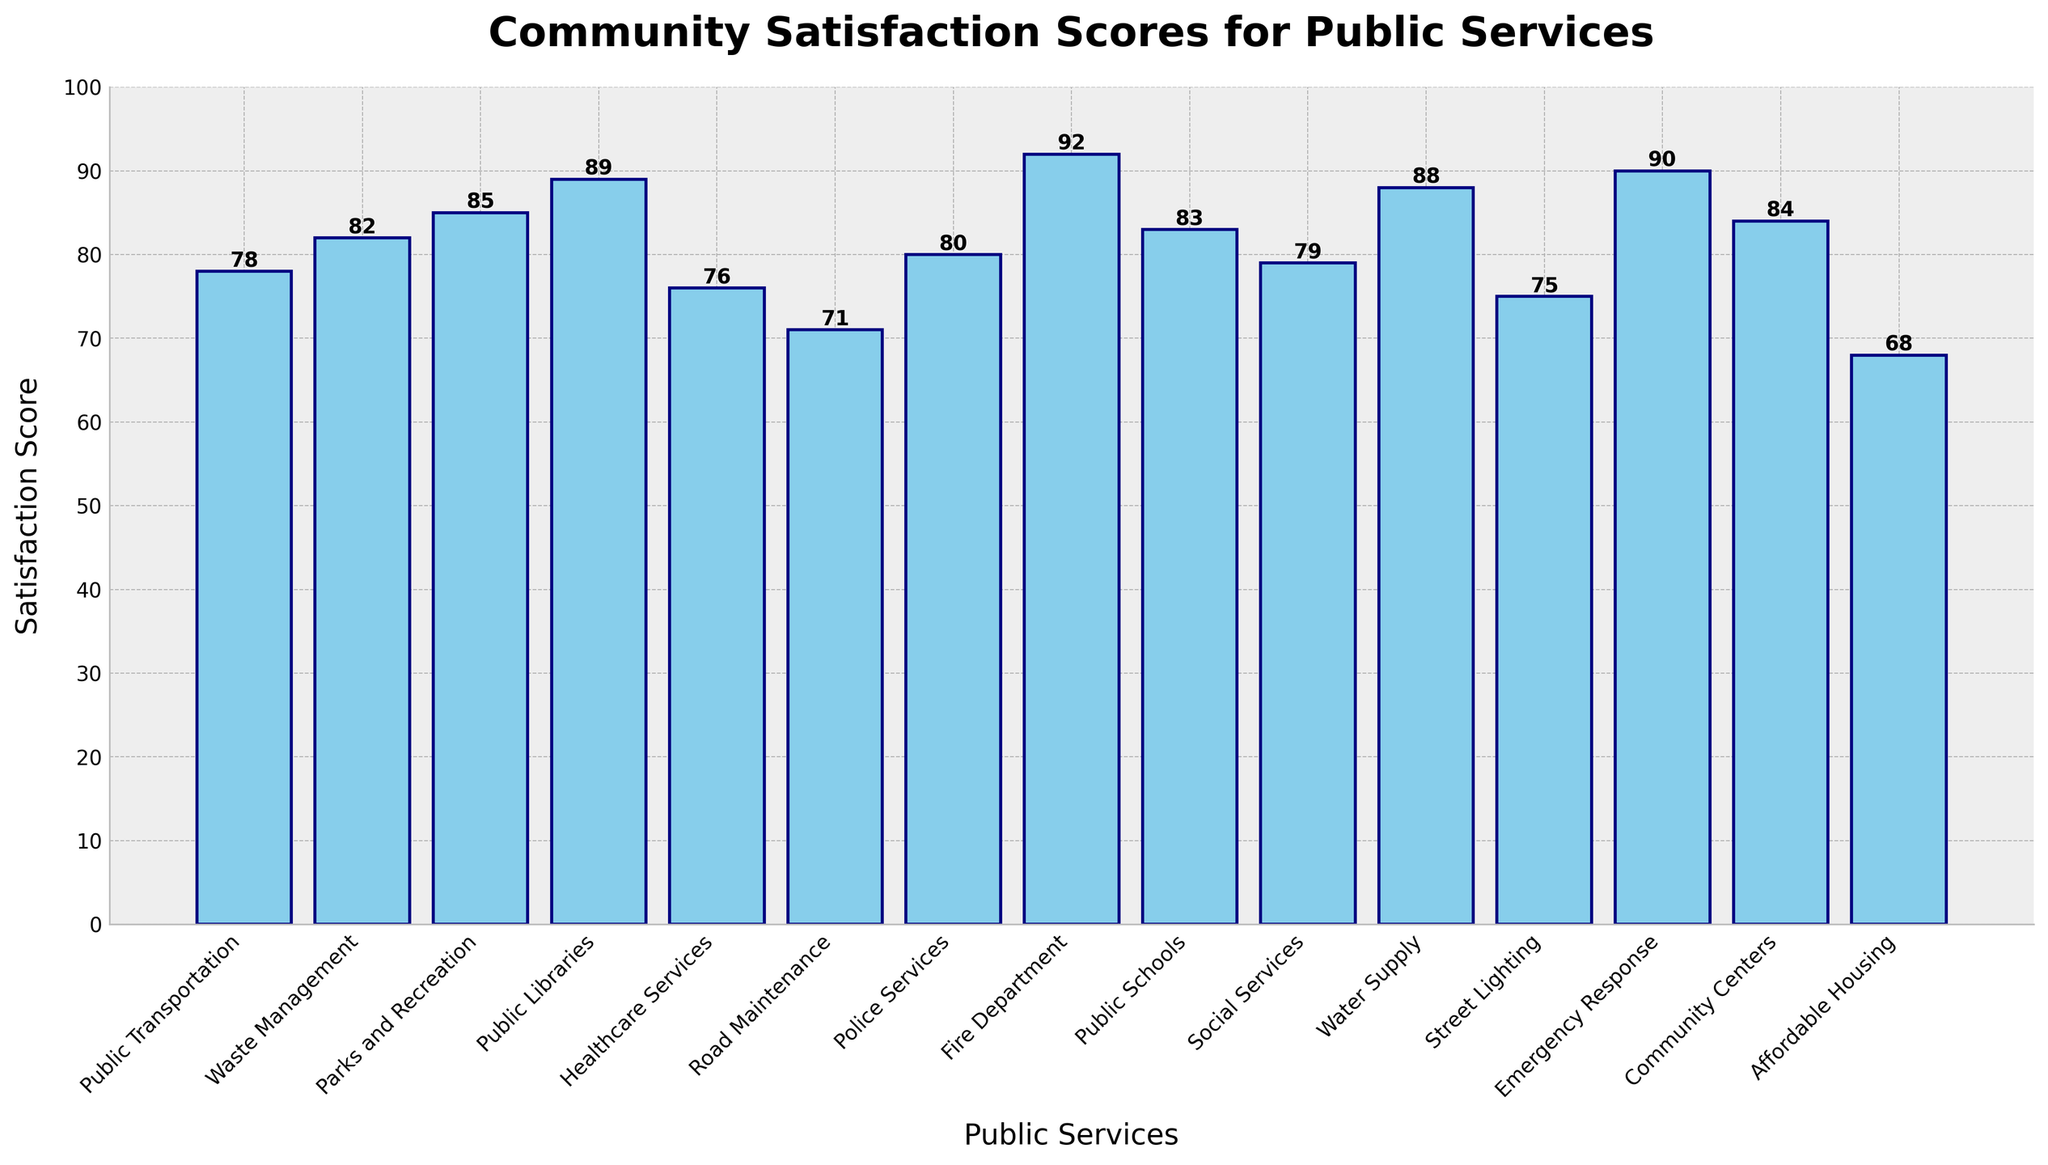What is the highest community satisfaction score among the public services? The tallest bar represents the service with the highest satisfaction score. According to the chart, the Fire Department has the highest satisfaction score of 92.
Answer: 92 Which public service has the lowest satisfaction score? The shortest bar indicates the lowest satisfaction score. The Affordable Housing service has the lowest satisfaction score of 68.
Answer: Affordable Housing How many public services have a satisfaction score above 80? Count the number of bars with a height greater than 80. The services are Waste Management, Parks and Recreation, Public Libraries, Fire Department, Public Schools, Water Supply, Emergency Response, and Community Centers, totaling 8.
Answer: 8 Compare the satisfaction scores of Healthcare Services and Community Centers. Which one is higher and by how much? Healthcare Services has a satisfaction score of 76, and Community Centers have 84. Subtract 76 from 84 to find the difference. Community Centers have a higher score by 8 points.
Answer: Community Centers by 8 What is the average satisfaction score of all the public services? Sum of all the satisfaction scores (78 + 82 + 85 + 89 + 76 + 71 + 80 + 92 + 83 + 79 + 88 + 75 + 90 + 84 + 68) is 1240. There are 15 services, so divide 1240 by 15. The average satisfaction score is approximately 82.67.
Answer: 82.67 Is the satisfaction score for Street Lighting greater or less than the average satisfaction score of all services? The satisfaction score for Street Lighting is 75. The average satisfaction score calculated is 82.67. Since 75 is less than 82.67, the score for Street Lighting is below average.
Answer: Less Which two public services have the closest satisfaction scores? Identify bars with similar heights. Public Libraries (89) and Water Supply (88) have a difference of 1 point, which is the smallest difference between any two services.
Answer: Public Libraries and Water Supply What is the combined satisfaction score for the Police Services and Fire Department? Add the satisfaction scores of Police Services (80) and Fire Department (92). The total is 80 + 92 = 172.
Answer: 172 Does Public Transportation have a higher satisfaction score compared to Social Services? Public Transportation has a satisfaction score of 78, and Social Services have 79. Since 78 is less than 79, Public Transportation has a lower satisfaction score.
Answer: No Rank the following services in descending order based on their satisfaction scores: Parks and Recreation, Public Schools, and Emergency Response. The satisfaction scores are Parks and Recreation (85), Public Schools (83), and Emergency Response (90). In descending order, it is Emergency Response, Parks and Recreation, and Public Schools.
Answer: Emergency Response, Parks and Recreation, Public Schools 